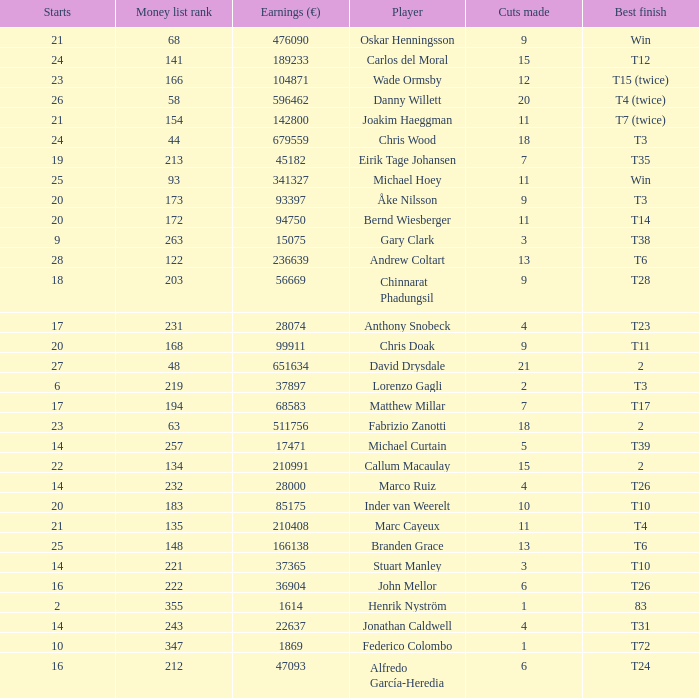How many cuts did Bernd Wiesberger make? 11.0. 